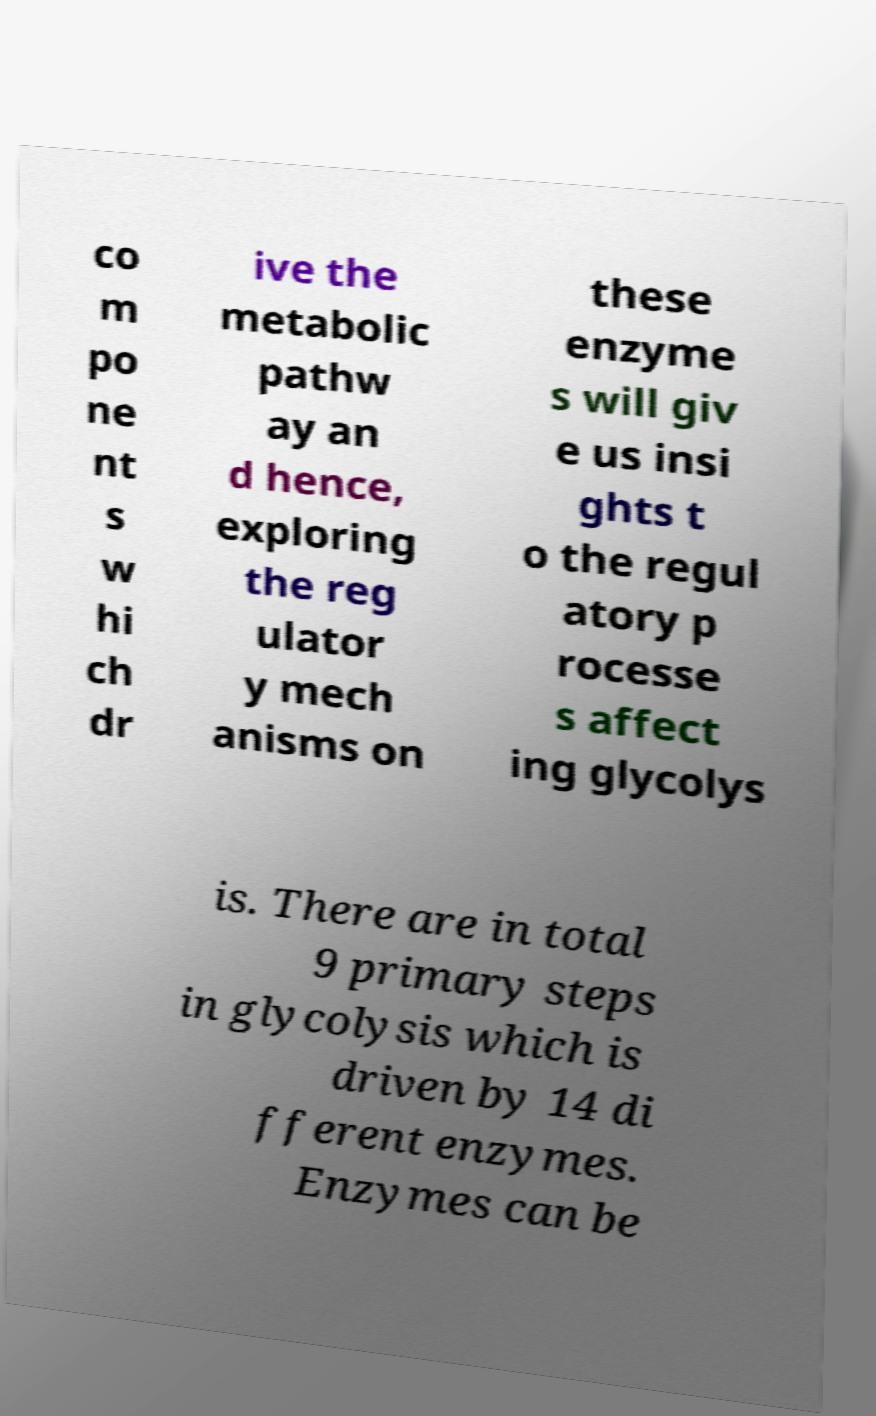There's text embedded in this image that I need extracted. Can you transcribe it verbatim? co m po ne nt s w hi ch dr ive the metabolic pathw ay an d hence, exploring the reg ulator y mech anisms on these enzyme s will giv e us insi ghts t o the regul atory p rocesse s affect ing glycolys is. There are in total 9 primary steps in glycolysis which is driven by 14 di fferent enzymes. Enzymes can be 